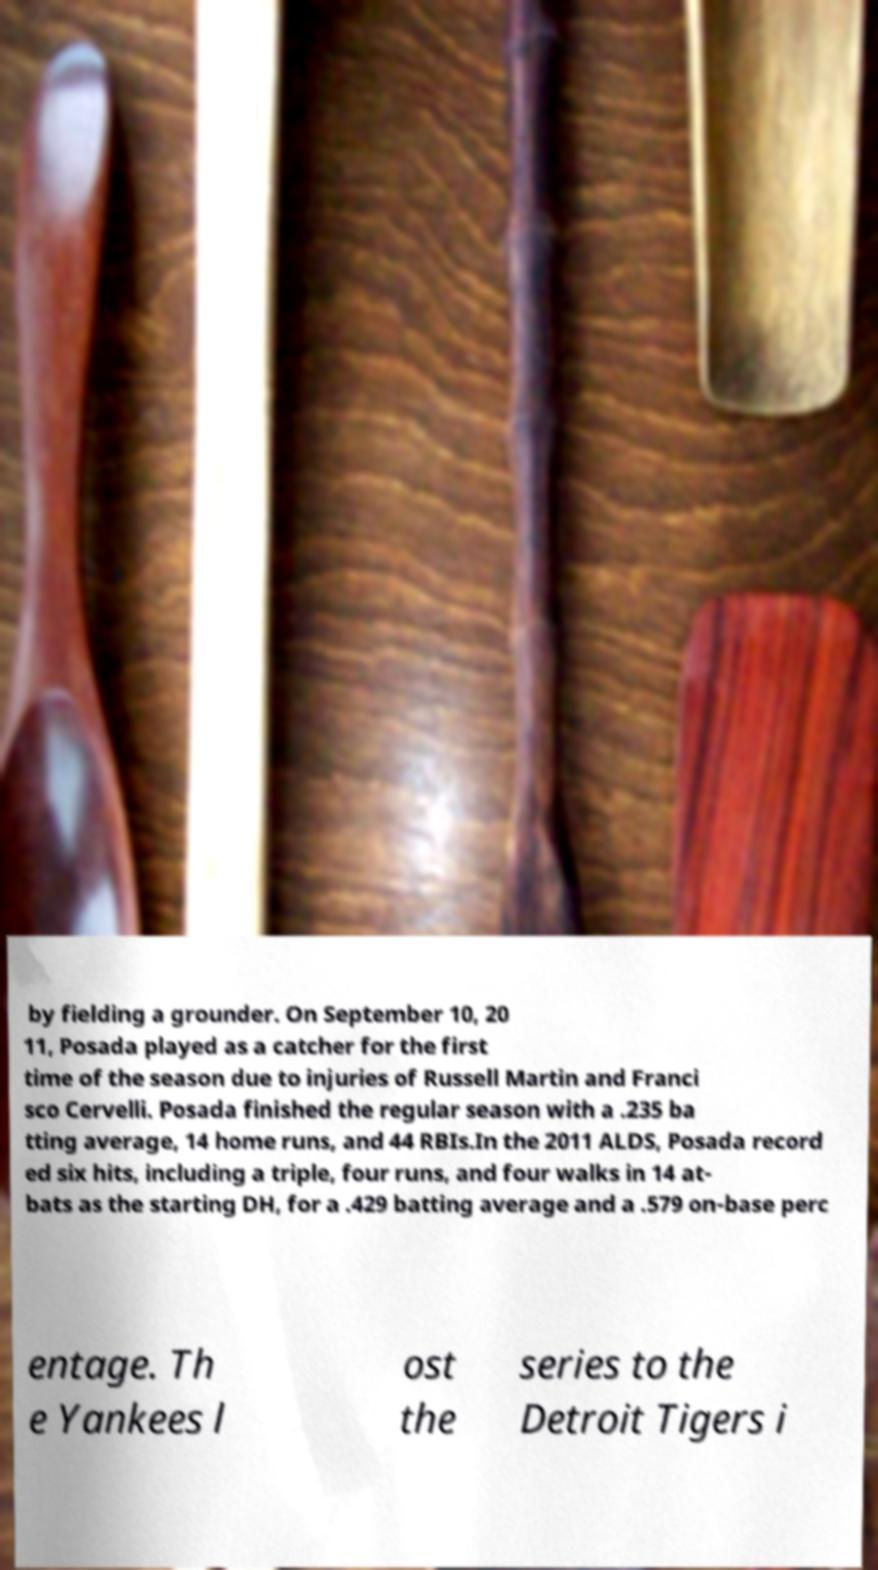I need the written content from this picture converted into text. Can you do that? by fielding a grounder. On September 10, 20 11, Posada played as a catcher for the first time of the season due to injuries of Russell Martin and Franci sco Cervelli. Posada finished the regular season with a .235 ba tting average, 14 home runs, and 44 RBIs.In the 2011 ALDS, Posada record ed six hits, including a triple, four runs, and four walks in 14 at- bats as the starting DH, for a .429 batting average and a .579 on-base perc entage. Th e Yankees l ost the series to the Detroit Tigers i 